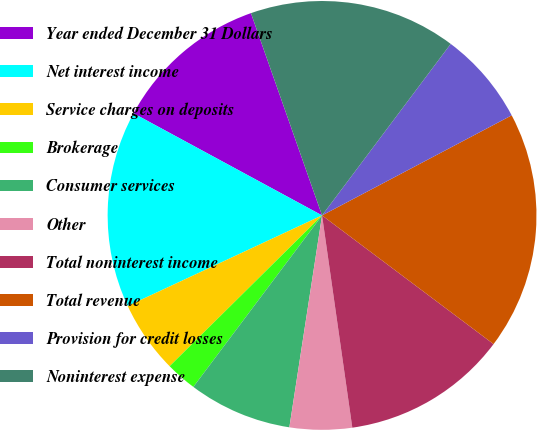Convert chart. <chart><loc_0><loc_0><loc_500><loc_500><pie_chart><fcel>Year ended December 31 Dollars<fcel>Net interest income<fcel>Service charges on deposits<fcel>Brokerage<fcel>Consumer services<fcel>Other<fcel>Total noninterest income<fcel>Total revenue<fcel>Provision for credit losses<fcel>Noninterest expense<nl><fcel>11.72%<fcel>14.84%<fcel>5.47%<fcel>2.34%<fcel>7.81%<fcel>4.69%<fcel>12.5%<fcel>17.97%<fcel>7.03%<fcel>15.62%<nl></chart> 